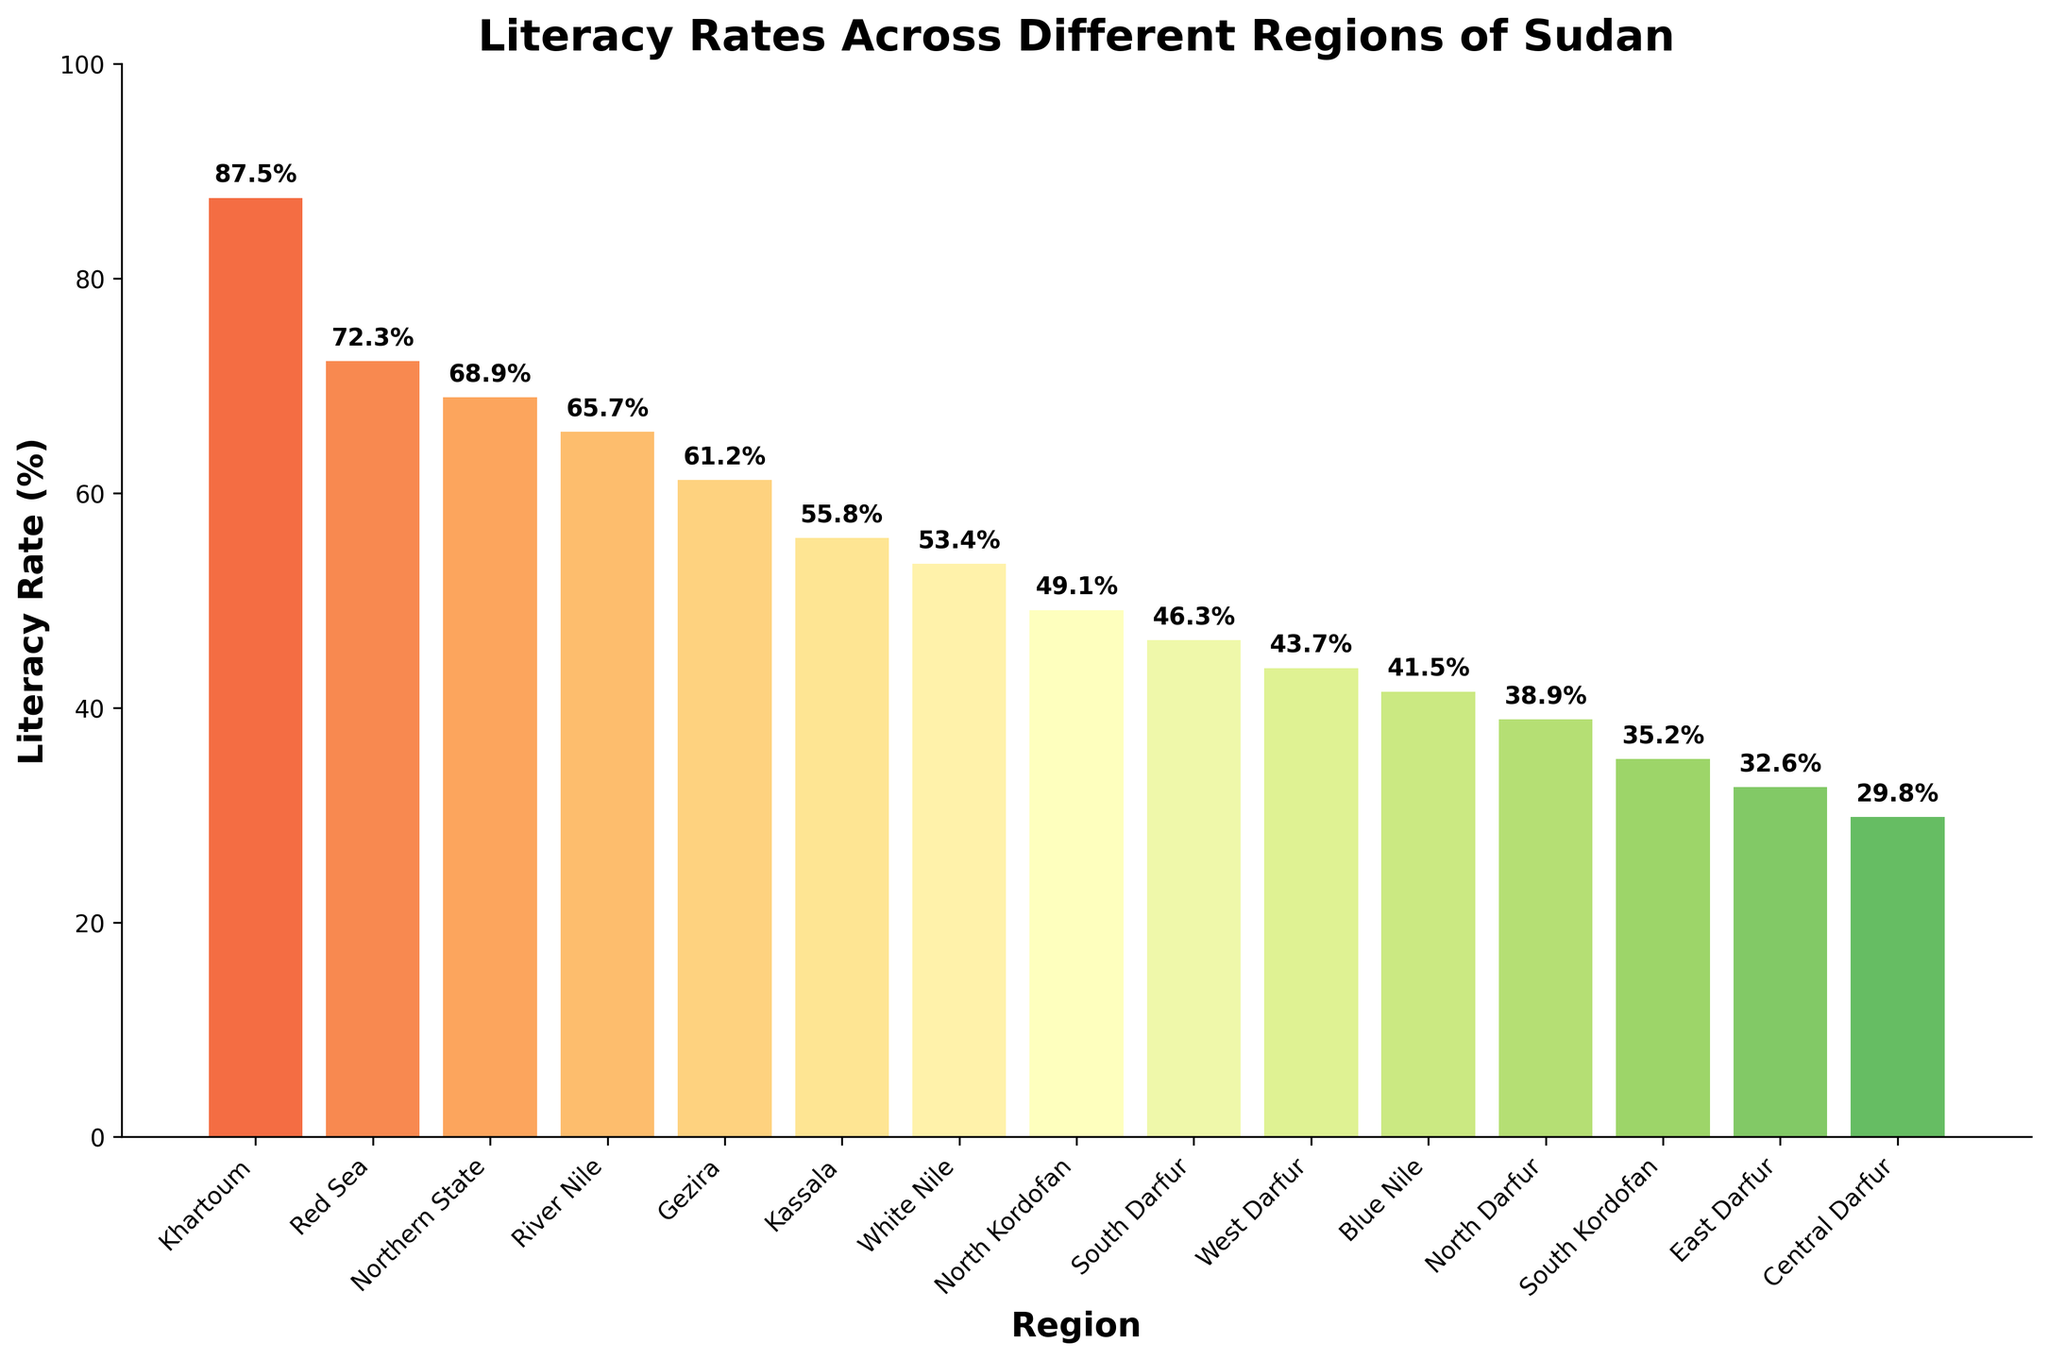Which region has the highest literacy rate? The highest bar in the chart represents the region with the highest literacy rate. Khartoum has the tallest bar with a literacy rate of 87.5%.
Answer: Khartoum Which region has the lowest literacy rate? The lowest bar in the chart shows the region with the lowest literacy rate. Central Darfur has the shortest bar with a literacy rate of 29.8%.
Answer: Central Darfur What is the difference in literacy rates between Khartoum and Central Darfur? To find the difference, subtract the literacy rate of Central Darfur from that of Khartoum. Khartoum's rate is 87.5%, and Central Darfur's rate is 29.8%. So, 87.5 - 29.8 = 57.7.
Answer: 57.7% Which regions have a literacy rate above 70%? The bars extending above the 70% mark represent regions with literacy rates above 70%. The regions are Khartoum (87.5%) and Red Sea (72.3%).
Answer: Khartoum, Red Sea What is the average literacy rate across all regions? Sum up all the literacy rates and divide by the number of regions. (87.5 + 72.3 + 68.9 + 65.7 + 61.2 + 55.8 + 53.4 + 49.1 + 46.3 + 43.7 + 41.5 + 38.9 + 35.2 + 32.6 + 29.8) / 15 ≈ 52.5.
Answer: 52.5% Which region has a literacy rate closest to the average rate? First, calculate the average rate as done previously (52.5%). Then, compare each region's rate to the average to find the closest value. White Nile with 53.4% is nearest to 52.5%.
Answer: White Nile How many regions have a literacy rate below 50%? Identify the regions with bars below the 50% mark. These regions are North Kordofan, South Darfur, West Darfur, Blue Nile, North Darfur, South Kordofan, East Darfur, Central Darfur. There are 8 regions in total.
Answer: 8 Compare the literacy rates of the Northern State and Gezira. Which one is higher? Locate the bars for both Northern State (68.9%) and Gezira (61.2%). The bar for Northern State is higher than that for Gezira.
Answer: Northern State What is the combined literacy rate of Kassala and White Nile? Add the literacy rates of Kassala (55.8%) and White Nile (53.4%). 55.8 + 53.4 = 109.2.
Answer: 109.2% What percentage of regions have a literacy rate above 60%? Identify regions with literacy rates above 60%: Khartoum, Red Sea, Northern State, River Nile, Gezira. There are 5 out of 15 regions. Calculate the percentage: (5/15) * 100 = 33.33%.
Answer: 33.33% 